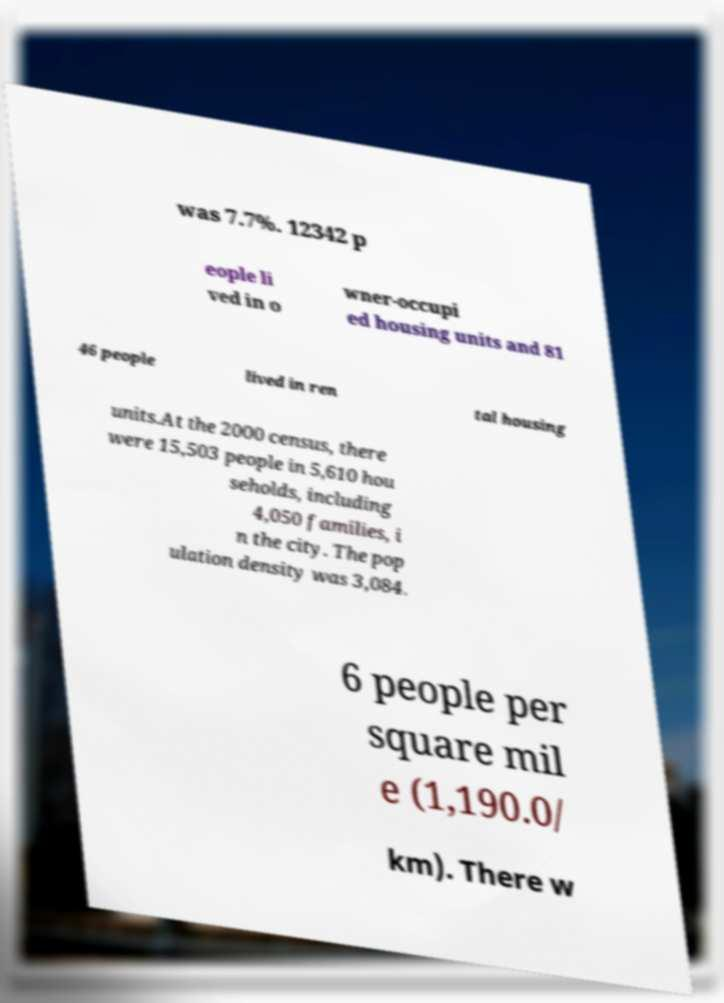Could you extract and type out the text from this image? was 7.7%. 12342 p eople li ved in o wner-occupi ed housing units and 81 46 people lived in ren tal housing units.At the 2000 census, there were 15,503 people in 5,610 hou seholds, including 4,050 families, i n the city. The pop ulation density was 3,084. 6 people per square mil e (1,190.0/ km). There w 